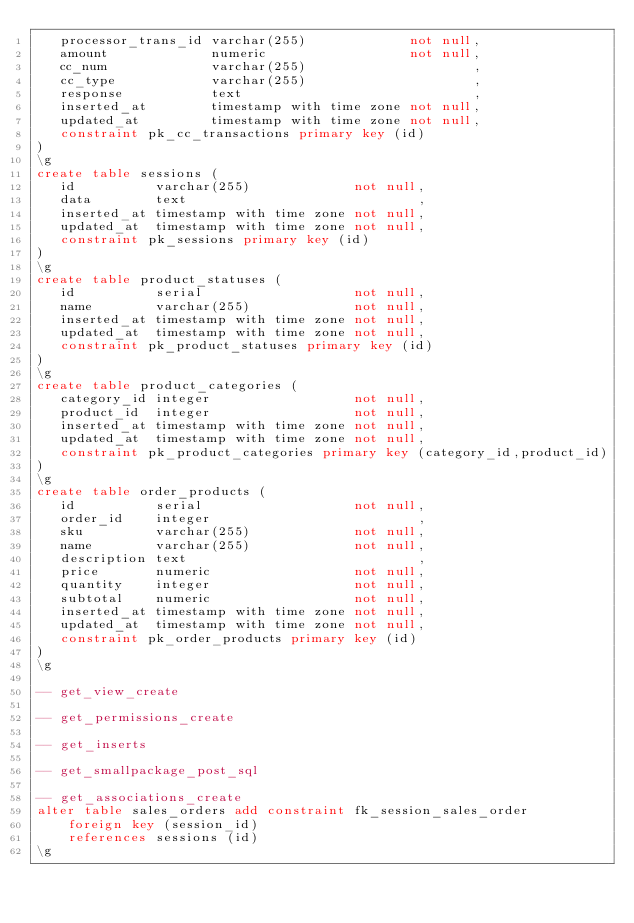<code> <loc_0><loc_0><loc_500><loc_500><_SQL_>   processor_trans_id varchar(255)             not null,
   amount             numeric                  not null,
   cc_num             varchar(255)                     ,
   cc_type            varchar(255)                     ,
   response           text                             ,
   inserted_at        timestamp with time zone not null,
   updated_at         timestamp with time zone not null,
   constraint pk_cc_transactions primary key (id)
)   
\g
create table sessions (
   id          varchar(255)             not null,
   data        text                             ,
   inserted_at timestamp with time zone not null,
   updated_at  timestamp with time zone not null,
   constraint pk_sessions primary key (id)
)   
\g
create table product_statuses (
   id          serial                   not null,
   name        varchar(255)             not null,
   inserted_at timestamp with time zone not null,
   updated_at  timestamp with time zone not null,
   constraint pk_product_statuses primary key (id)
)   
\g
create table product_categories (
   category_id integer                  not null,
   product_id  integer                  not null,
   inserted_at timestamp with time zone not null,
   updated_at  timestamp with time zone not null,
   constraint pk_product_categories primary key (category_id,product_id)
)   
\g
create table order_products (
   id          serial                   not null,
   order_id    integer                          ,
   sku         varchar(255)             not null,
   name        varchar(255)             not null,
   description text                             ,
   price       numeric                  not null,
   quantity    integer                  not null,
   subtotal    numeric                  not null,
   inserted_at timestamp with time zone not null,
   updated_at  timestamp with time zone not null,
   constraint pk_order_products primary key (id)
)   
\g

-- get_view_create

-- get_permissions_create

-- get_inserts

-- get_smallpackage_post_sql

-- get_associations_create
alter table sales_orders add constraint fk_session_sales_order 
    foreign key (session_id)
    references sessions (id) 
\g
</code> 